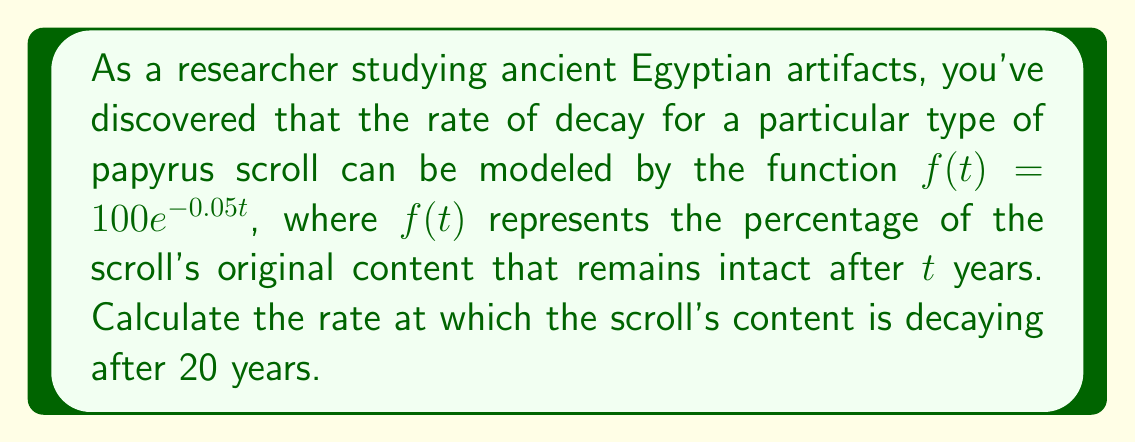Provide a solution to this math problem. To solve this problem, we need to find the derivative of the given function and evaluate it at t = 20. Let's break it down step-by-step:

1) The given function is $f(t) = 100e^{-0.05t}$

2) To find the rate of decay, we need to calculate $f'(t)$. Using the chain rule:

   $f'(t) = 100 \cdot \frac{d}{dt}(e^{-0.05t})$
   $f'(t) = 100 \cdot (-0.05) \cdot e^{-0.05t}$
   $f'(t) = -5e^{-0.05t}$

3) Now that we have the derivative, we can evaluate it at t = 20:

   $f'(20) = -5e^{-0.05(20)}$
   $f'(20) = -5e^{-1}$

4) To calculate this:
   $e^{-1} \approx 0.3679$
   $f'(20) \approx -5 \cdot 0.3679 = -1.8395$

5) The negative sign indicates that the content is decreasing over time.

Therefore, after 20 years, the scroll's content is decaying at a rate of approximately 1.8395% per year.
Answer: $-1.8395\%$ per year 